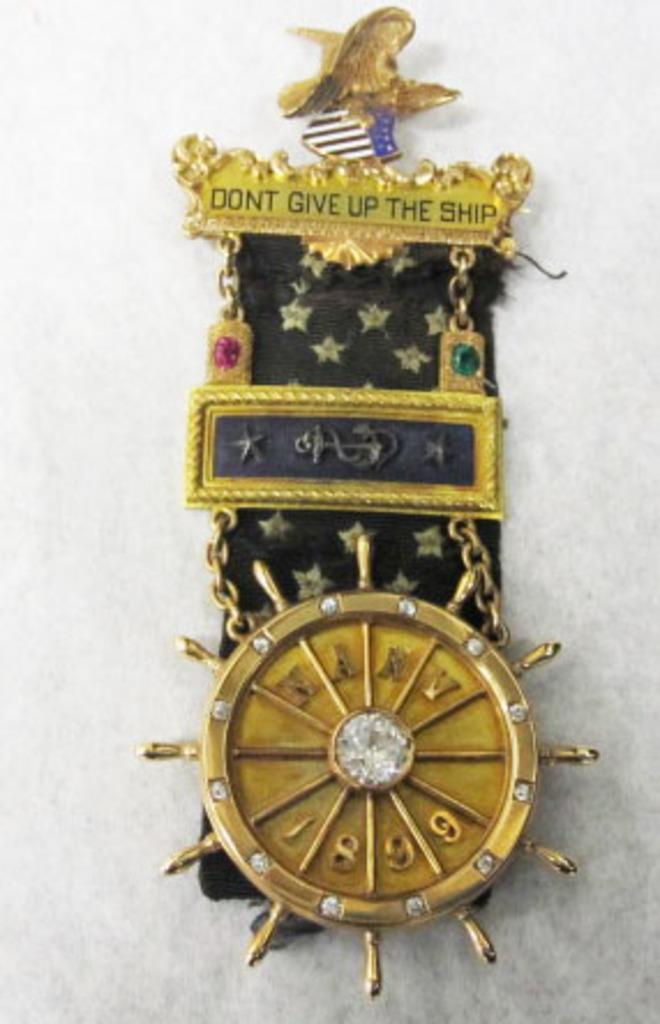<image>
Give a short and clear explanation of the subsequent image. The medallion urges you to don't give up the ship. 